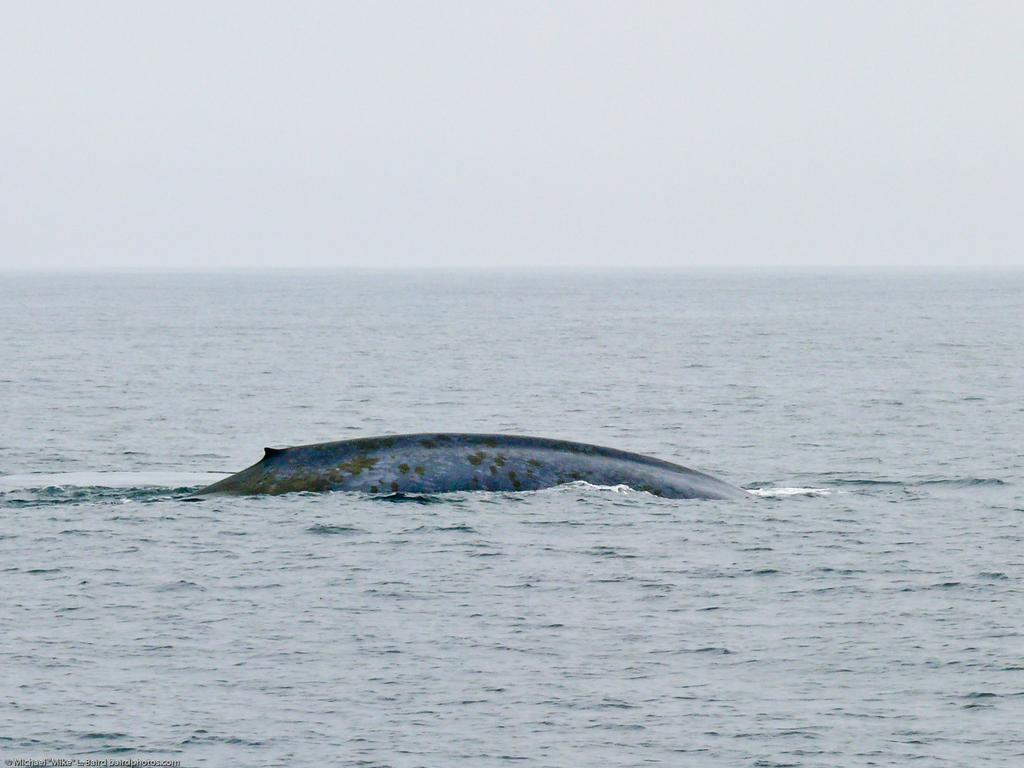Where was the image taken? The image was clicked near the ocean. What can be seen at the bottom of the image? There is water at the bottom of the image. What is the main subject in the middle of the image? There appears to be a whale in the middle of the image. What is visible at the top of the image? The sky is visible at the top of the image. What statement is written on the note attached to the whale's fin in the image? There is no note or statement present in the image; it features a whale in the water. 